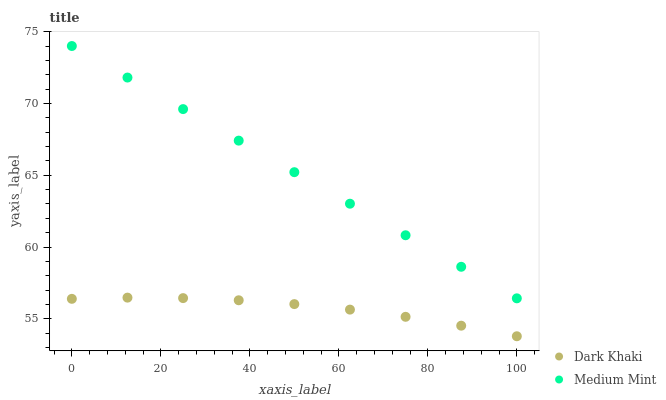Does Dark Khaki have the minimum area under the curve?
Answer yes or no. Yes. Does Medium Mint have the maximum area under the curve?
Answer yes or no. Yes. Does Medium Mint have the minimum area under the curve?
Answer yes or no. No. Is Medium Mint the smoothest?
Answer yes or no. Yes. Is Dark Khaki the roughest?
Answer yes or no. Yes. Is Medium Mint the roughest?
Answer yes or no. No. Does Dark Khaki have the lowest value?
Answer yes or no. Yes. Does Medium Mint have the lowest value?
Answer yes or no. No. Does Medium Mint have the highest value?
Answer yes or no. Yes. Is Dark Khaki less than Medium Mint?
Answer yes or no. Yes. Is Medium Mint greater than Dark Khaki?
Answer yes or no. Yes. Does Dark Khaki intersect Medium Mint?
Answer yes or no. No. 